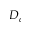Convert formula to latex. <formula><loc_0><loc_0><loc_500><loc_500>D _ { c }</formula> 